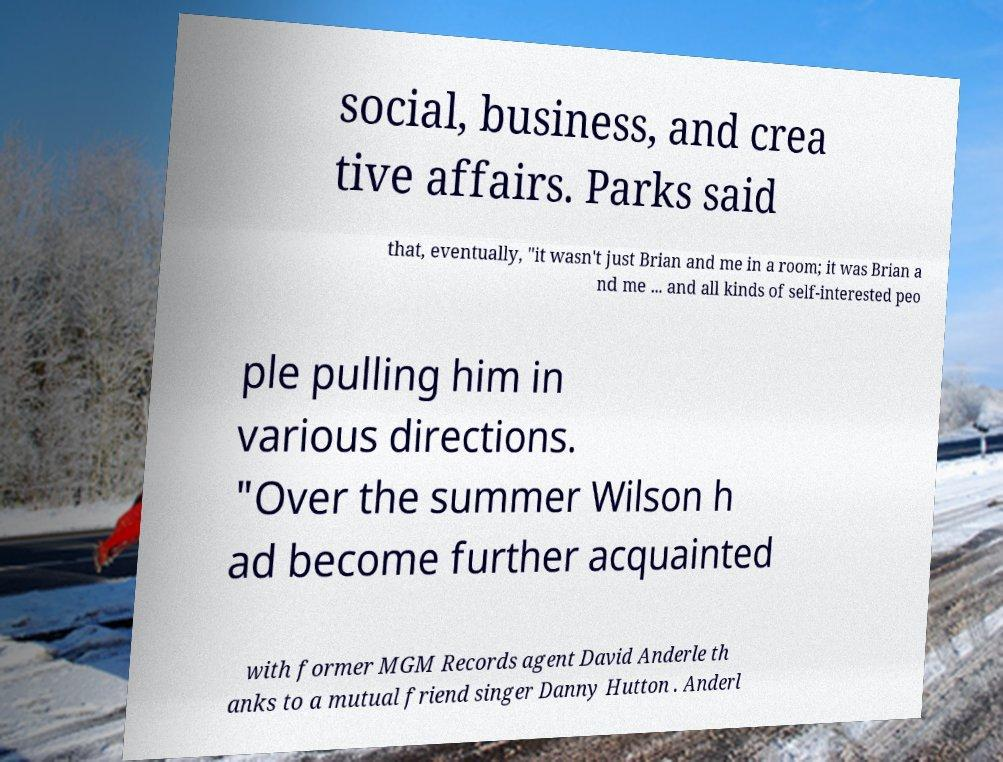What messages or text are displayed in this image? I need them in a readable, typed format. social, business, and crea tive affairs. Parks said that, eventually, "it wasn't just Brian and me in a room; it was Brian a nd me ... and all kinds of self-interested peo ple pulling him in various directions. "Over the summer Wilson h ad become further acquainted with former MGM Records agent David Anderle th anks to a mutual friend singer Danny Hutton . Anderl 